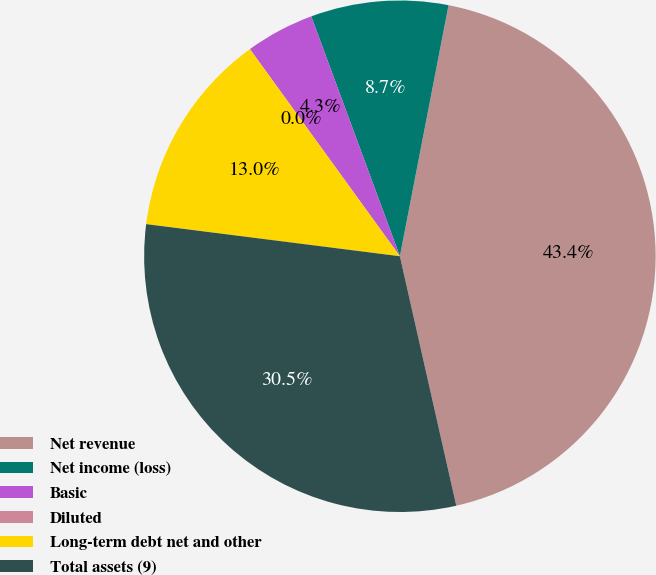Convert chart. <chart><loc_0><loc_0><loc_500><loc_500><pie_chart><fcel>Net revenue<fcel>Net income (loss)<fcel>Basic<fcel>Diluted<fcel>Long-term debt net and other<fcel>Total assets (9)<nl><fcel>43.41%<fcel>8.68%<fcel>4.34%<fcel>0.0%<fcel>13.02%<fcel>30.54%<nl></chart> 